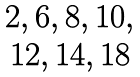Convert formula to latex. <formula><loc_0><loc_0><loc_500><loc_500>\begin{matrix} 2 , 6 , 8 , 1 0 , \\ 1 2 , 1 4 , 1 8 \end{matrix}</formula> 